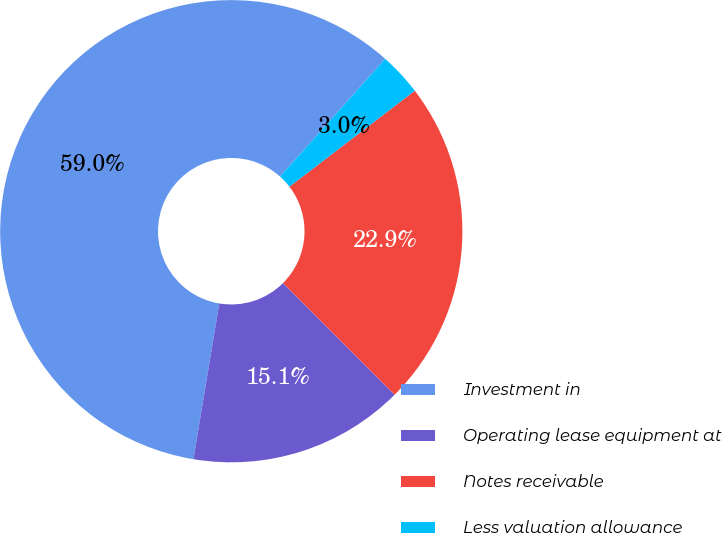<chart> <loc_0><loc_0><loc_500><loc_500><pie_chart><fcel>Investment in<fcel>Operating lease equipment at<fcel>Notes receivable<fcel>Less valuation allowance<nl><fcel>58.99%<fcel>15.11%<fcel>22.91%<fcel>3.0%<nl></chart> 